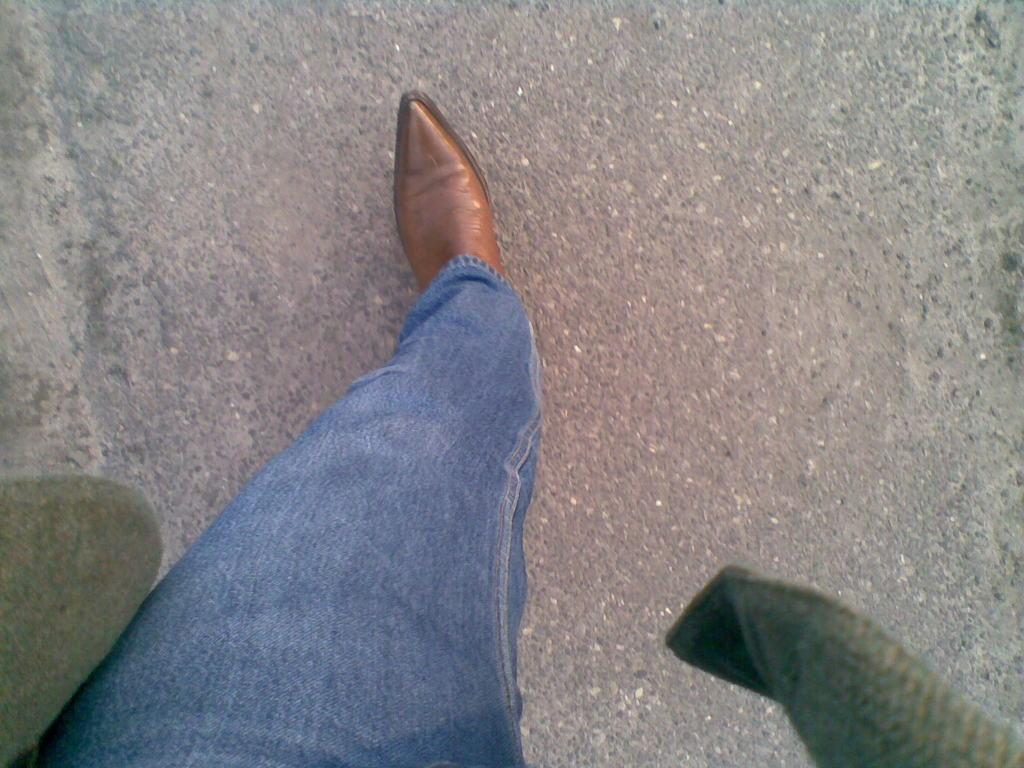What is the main subject of the image? There is a person in the image. What is the person wearing on their upper body? The person is wearing a green jacket. What type of pants is the person wearing? The person is wearing jeans. What type of shoes is the person wearing? The person is wearing brown shoes. What is the person doing in the image? The person is walking on the road. What type of tin can be seen in the person's hand in the image? There is no tin present in the person's hand or in the image. 